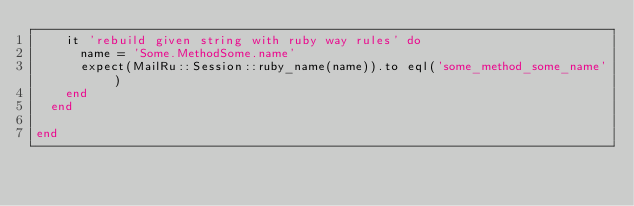Convert code to text. <code><loc_0><loc_0><loc_500><loc_500><_Ruby_>    it 'rebuild given string with ruby way rules' do
      name = 'Some.MethodSome.name'
      expect(MailRu::Session::ruby_name(name)).to eql('some_method_some_name')
    end
  end

end
</code> 